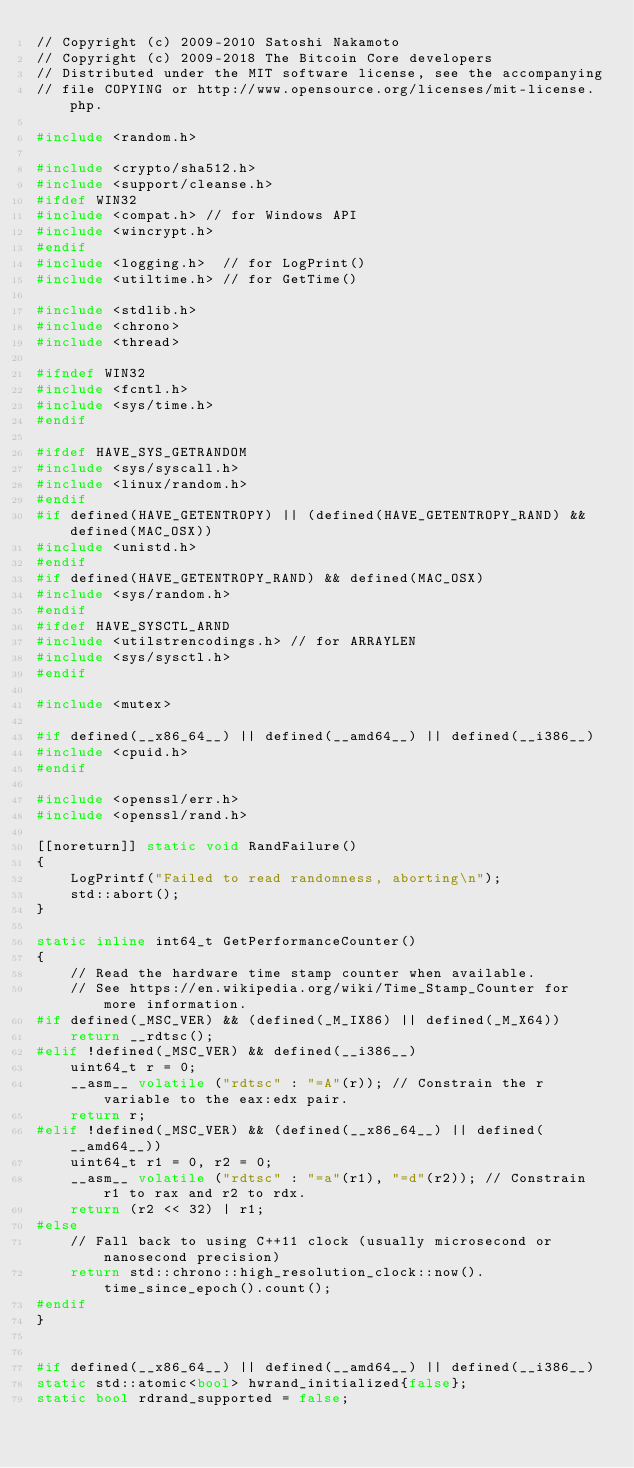<code> <loc_0><loc_0><loc_500><loc_500><_C++_>// Copyright (c) 2009-2010 Satoshi Nakamoto
// Copyright (c) 2009-2018 The Bitcoin Core developers
// Distributed under the MIT software license, see the accompanying
// file COPYING or http://www.opensource.org/licenses/mit-license.php.

#include <random.h>

#include <crypto/sha512.h>
#include <support/cleanse.h>
#ifdef WIN32
#include <compat.h> // for Windows API
#include <wincrypt.h>
#endif
#include <logging.h>  // for LogPrint()
#include <utiltime.h> // for GetTime()

#include <stdlib.h>
#include <chrono>
#include <thread>

#ifndef WIN32
#include <fcntl.h>
#include <sys/time.h>
#endif

#ifdef HAVE_SYS_GETRANDOM
#include <sys/syscall.h>
#include <linux/random.h>
#endif
#if defined(HAVE_GETENTROPY) || (defined(HAVE_GETENTROPY_RAND) && defined(MAC_OSX))
#include <unistd.h>
#endif
#if defined(HAVE_GETENTROPY_RAND) && defined(MAC_OSX)
#include <sys/random.h>
#endif
#ifdef HAVE_SYSCTL_ARND
#include <utilstrencodings.h> // for ARRAYLEN
#include <sys/sysctl.h>
#endif

#include <mutex>

#if defined(__x86_64__) || defined(__amd64__) || defined(__i386__)
#include <cpuid.h>
#endif

#include <openssl/err.h>
#include <openssl/rand.h>

[[noreturn]] static void RandFailure()
{
    LogPrintf("Failed to read randomness, aborting\n");
    std::abort();
}

static inline int64_t GetPerformanceCounter()
{
    // Read the hardware time stamp counter when available.
    // See https://en.wikipedia.org/wiki/Time_Stamp_Counter for more information.
#if defined(_MSC_VER) && (defined(_M_IX86) || defined(_M_X64))
    return __rdtsc();
#elif !defined(_MSC_VER) && defined(__i386__)
    uint64_t r = 0;
    __asm__ volatile ("rdtsc" : "=A"(r)); // Constrain the r variable to the eax:edx pair.
    return r;
#elif !defined(_MSC_VER) && (defined(__x86_64__) || defined(__amd64__))
    uint64_t r1 = 0, r2 = 0;
    __asm__ volatile ("rdtsc" : "=a"(r1), "=d"(r2)); // Constrain r1 to rax and r2 to rdx.
    return (r2 << 32) | r1;
#else
    // Fall back to using C++11 clock (usually microsecond or nanosecond precision)
    return std::chrono::high_resolution_clock::now().time_since_epoch().count();
#endif
}


#if defined(__x86_64__) || defined(__amd64__) || defined(__i386__)
static std::atomic<bool> hwrand_initialized{false};
static bool rdrand_supported = false;</code> 